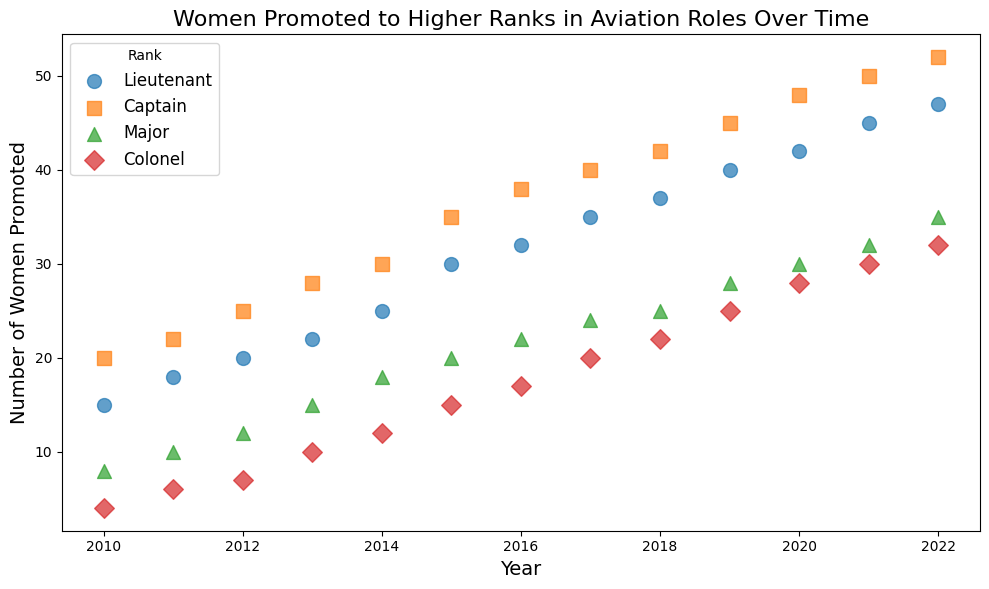What is the trend for the number of women promoted to the rank of Captain from 2010 to 2022? By observing the scatter points for 'Captain' over the years, we see that the number of women promoted has steadily increased from 20 in 2010 to 52 in 2022.
Answer: Increasing Which rank saw the most significant increase in the number of women promoted from 2010 to 2022? Comparing the starting and ending values for each rank: 
- "Lieutenant" from 15 to 47 
- "Captain" from 20 to 52 
- "Major" from 8 to 35 
- "Colonel" from 4 to 32
"Captain" saw the largest overall increase from 20 to 52, an increase of 32 promotions.
Answer: Captain In which year did the rank of Colonel have the most women promoted? By looking at the scatter points for 'Colonel' in different years, the promotion count reaches its highest at 32 in the year 2022.
Answer: 2022 How does the trend in the number of women promoted to Major compare to the trend in the number promoted to Lieutenant? The trend lines for both 'Major' and 'Lieutenant' indicate an upward trajectory over the years. However, the slope of the increase for 'Lieutenant' appears steeper than that for 'Major'. Therefore, the promotions for 'Lieutenant' are growing faster.
Answer: Lieutenant's trend is steeper What was the average number of women promoted to higher ranks per year for the rank of Major between 2010 and 2022? Summing the values for the rank of 'Major' (8 + 10 + 12 + 15 + 18 + 20 + 22 + 24 + 25 + 28 + 30 + 32 + 35) = 279. Then, dividing by the number of years (13), the average number of women promoted per year is approximately 21.46.
Answer: 21.46 Which rank had the least number of women promoted in 2016? For the year 2016, comparing the promotion values:
- "Lieutenant": 32
- "Captain": 38
- "Major": 22
- "Colonel": 17
'Colonel' had the least number of women promoted at 17.
Answer: Colonel Did the number of women promoted to Lieutenant ever surpass those promoted to Captain in any given year? Observing the scatter points for 'Lieutenant' and 'Captain', the number of women promoted to Lieutenant never surpasses those promoted to Captain in any year from 2010 to 2022.
Answer: No Is there a specific year where every rank saw an increase in the number of women promoted compared to the previous year? Comparing consecutive years:
- From 2019 to 2020: 
  - "Lieutenant": 40 to 42 (+2)
  - "Captain": 45 to 48 (+3)
  - "Major": 28 to 30 (+2)
  - "Colonel": 25 to 28 (+3)
All ranks had an increase in 2020 compared to 2019.
Answer: 2020 What's the total number of women promoted to higher ranks in 2021 across all ranks? Summing the 2021 values for all ranks:
- "Lieutenant": 45
- "Captain": 50
- "Major": 32
- "Colonel": 30
Total = 45 + 50 + 32 + 30 = 157
Answer: 157 